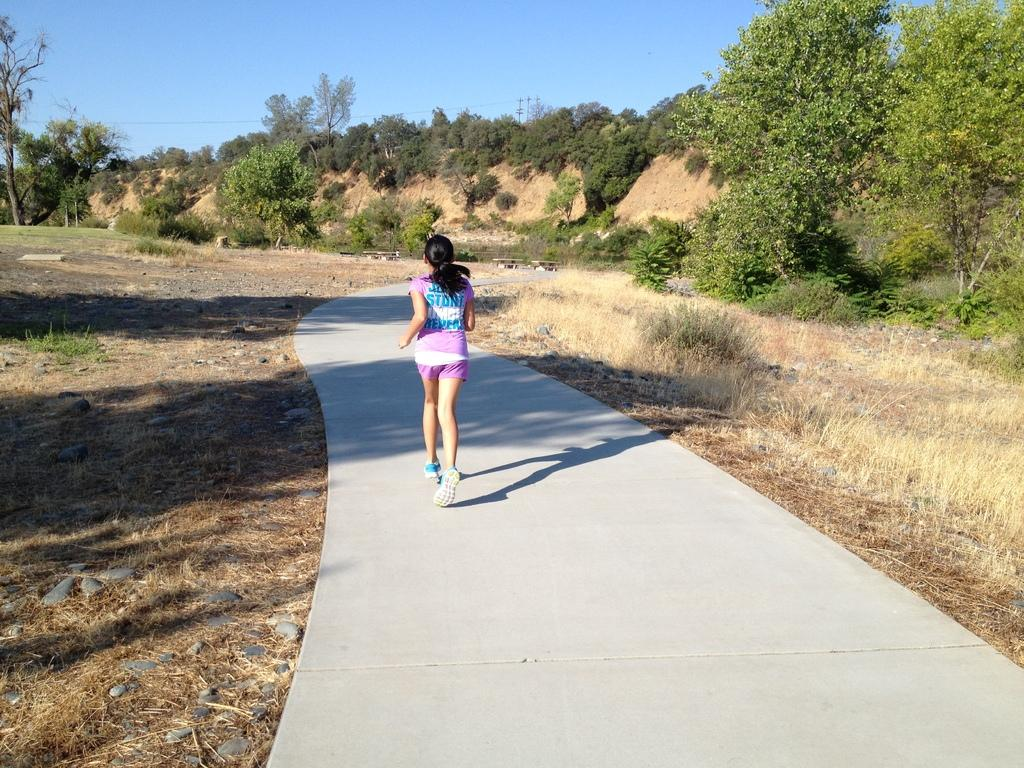What is the main subject of the image? There is a woman in the image. What is the woman doing in the image? The woman is running on the road. What can be seen on the ground in the image? The ground is visible in the image. What type of vegetation is present in the image? There is grass, plants, and trees in the image. What is visible in the background of the image? The sky is visible in the background of the image. What type of bread is the woman holding in the image? There is no bread present in the image; the woman is running on the road. What is the friction between the woman's shoes and the road in the image? The image does not provide information about the friction between the woman's shoes and the road. 